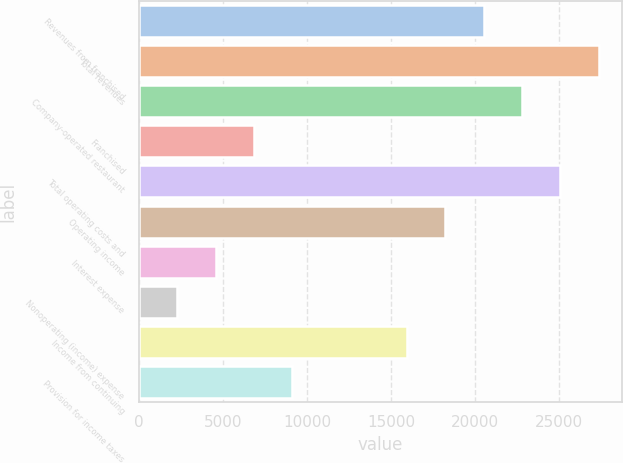Convert chart. <chart><loc_0><loc_0><loc_500><loc_500><bar_chart><fcel>Revenues from franchised<fcel>Total revenues<fcel>Company-operated restaurant<fcel>Franchised<fcel>Total operating costs and<fcel>Operating income<fcel>Interest expense<fcel>Nonoperating (income) expense<fcel>Income from continuing<fcel>Provision for income taxes<nl><fcel>20508.5<fcel>27344<fcel>22787<fcel>6837.46<fcel>25065.5<fcel>18230<fcel>4558.95<fcel>2280.44<fcel>15951.5<fcel>9115.97<nl></chart> 